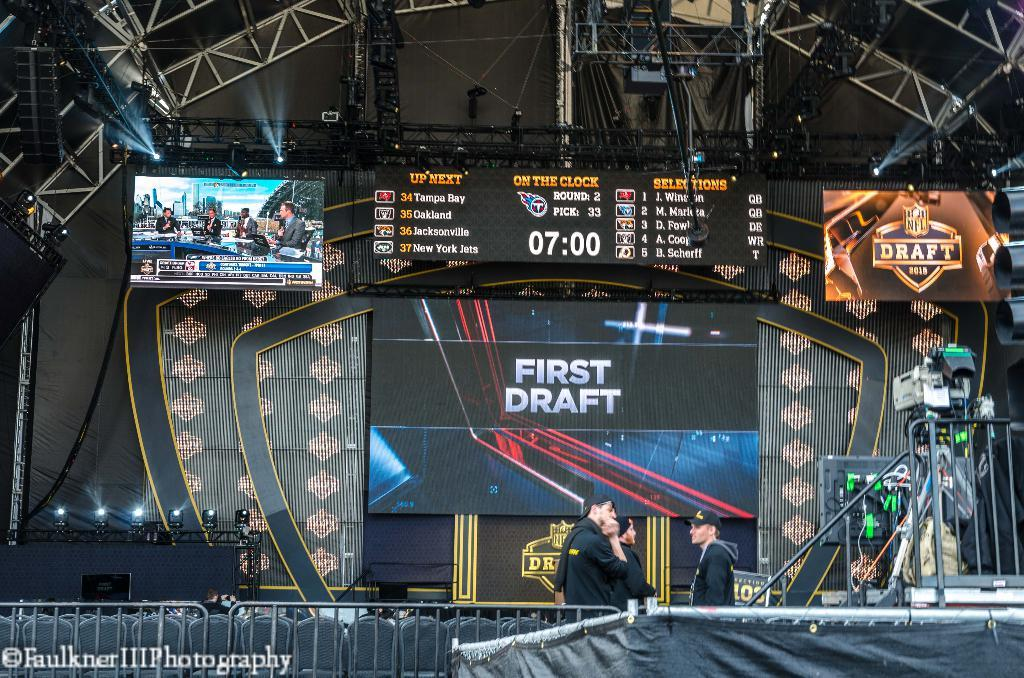<image>
Render a clear and concise summary of the photo. Big screens on a stage displaying the NFL draft. 